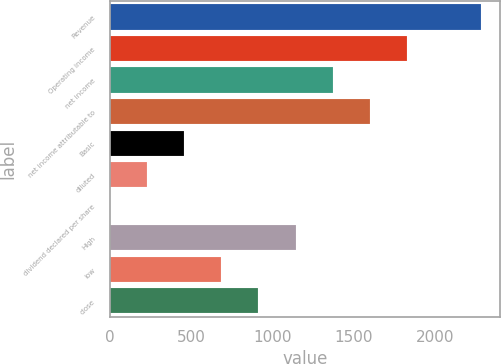Convert chart. <chart><loc_0><loc_0><loc_500><loc_500><bar_chart><fcel>Revenue<fcel>Operating income<fcel>net income<fcel>net income attributable to<fcel>Basic<fcel>diluted<fcel>dividend declared per share<fcel>High<fcel>low<fcel>close<nl><fcel>2282<fcel>1825.86<fcel>1369.74<fcel>1597.8<fcel>457.5<fcel>229.44<fcel>1.38<fcel>1141.68<fcel>685.56<fcel>913.62<nl></chart> 